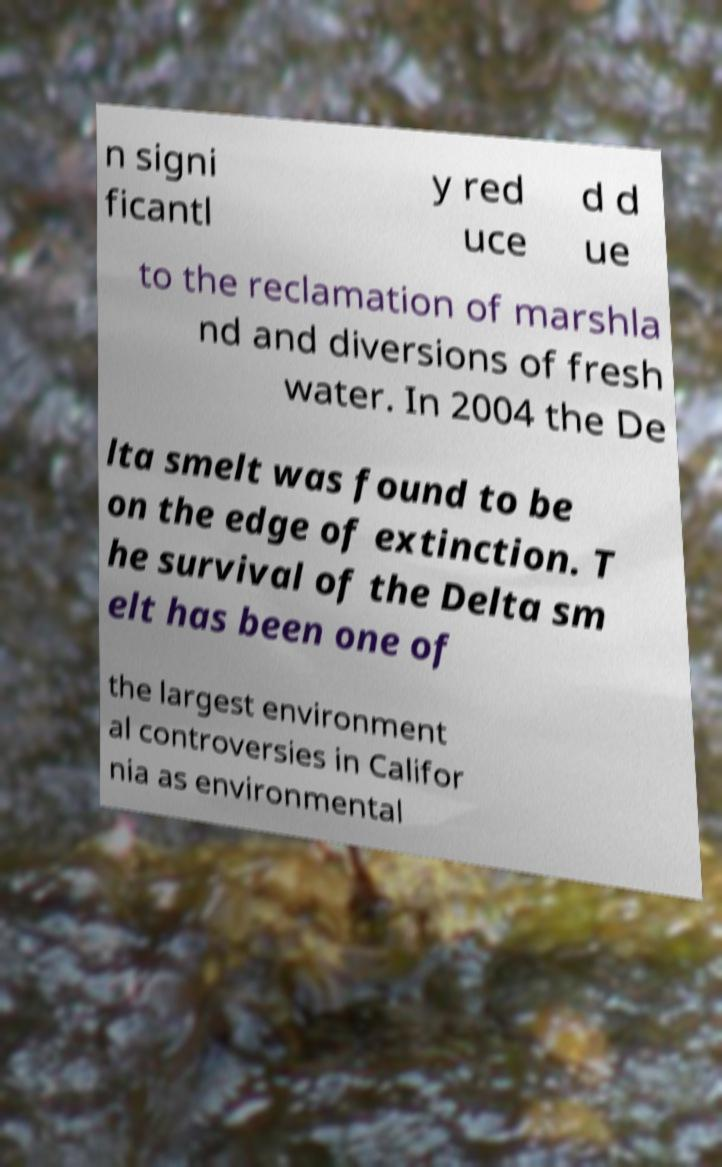Could you assist in decoding the text presented in this image and type it out clearly? n signi ficantl y red uce d d ue to the reclamation of marshla nd and diversions of fresh water. In 2004 the De lta smelt was found to be on the edge of extinction. T he survival of the Delta sm elt has been one of the largest environment al controversies in Califor nia as environmental 